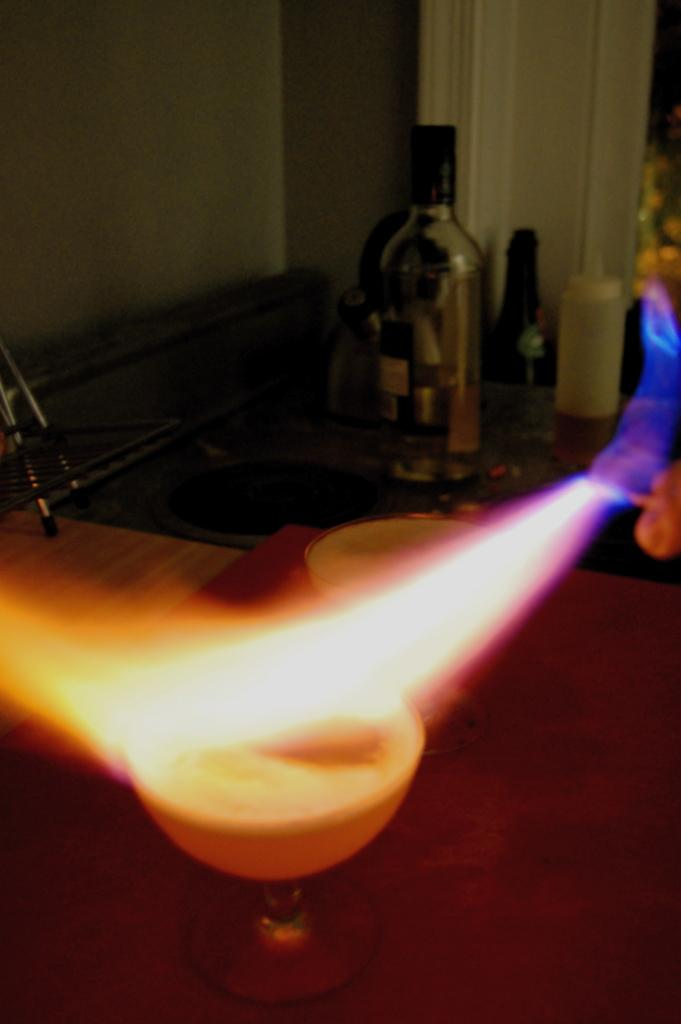What objects are on the table in the foreground of the image? There are two glasses on the table in the foreground of the image. What can be seen in the image besides the glasses on the table? There is a flame and alcohol bottles visible in the image. What type of cast can be seen walking through the snow in the image? There is no cast or snow present in the image; it features two glasses on a table, a flame, and alcohol bottles. 